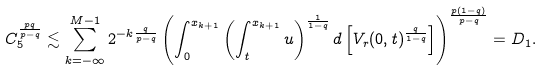Convert formula to latex. <formula><loc_0><loc_0><loc_500><loc_500>C _ { 5 } ^ { \frac { p q } { p - q } } & \lesssim \sum _ { k = - \infty } ^ { M - 1 } 2 ^ { - k \frac { q } { p - q } } \left ( \int _ { 0 } ^ { { x _ { k + 1 } } } \left ( \int _ { t } ^ { { x _ { k + 1 } } } u \right ) ^ { \frac { 1 } { 1 - q } } d \left [ V _ { r } ( 0 , t ) ^ { \frac { q } { 1 - q } } \right ] \right ) ^ { \frac { p ( 1 - q ) } { p - q } } = D _ { 1 } .</formula> 